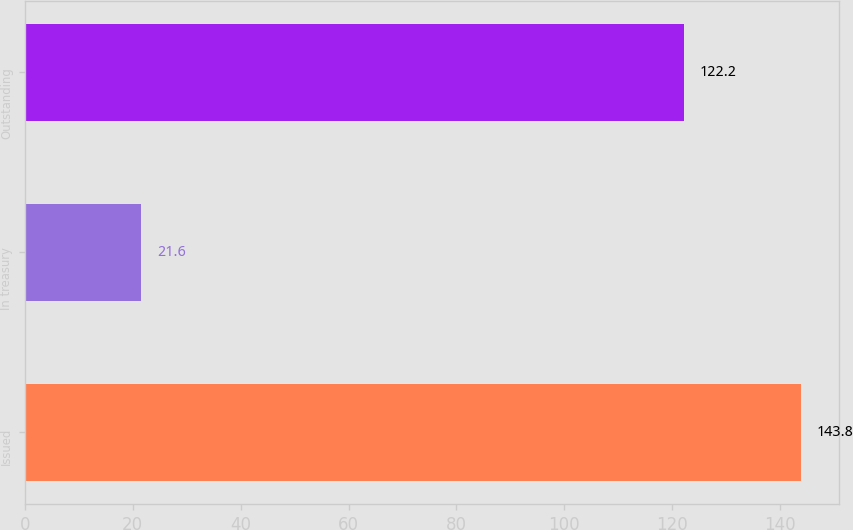Convert chart. <chart><loc_0><loc_0><loc_500><loc_500><bar_chart><fcel>Issued<fcel>In treasury<fcel>Outstanding<nl><fcel>143.8<fcel>21.6<fcel>122.2<nl></chart> 